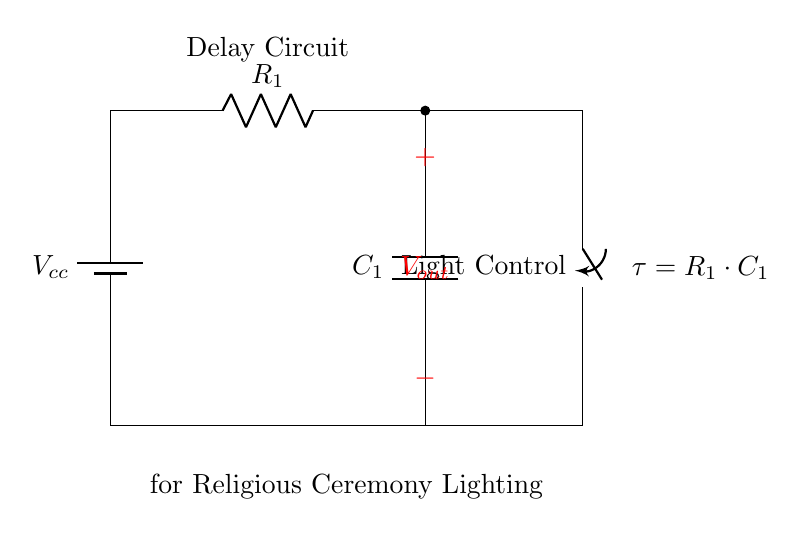What are the main components in this circuit? The main components are a resistor, a capacitor, and a switch. The resistor is labeled as R1, the capacitor as C1, and the switch is used for controlling the light.
Answer: resistor, capacitor, switch What does the capacitor do in this circuit? The capacitor charges and discharges, creating a delay in the output when the circuit is powered. This charging process determines how quickly the circuit responds, allowing for timed lighting effects.
Answer: Creates delay What is the purpose of the switch in this circuit? The switch controls the on/off state of the lighting connected to the circuit, allowing the lighting to be activated after the delay created by R1 and C1.
Answer: Control lighting What is the time constant of the circuit? The time constant (tau) is calculated using the formula tau equals R1 times C1. This determines how long the delay effect lasts based on the resistor and capacitor values.
Answer: R1 * C1 How does resistance affect the time delay in the circuit? Increasing resistance will increase the time constant, resulting in a longer delay for the lighting effect. Conversely, decreasing resistance will shorten the delay. The relationship is directly proportional.
Answer: Longer delay What will happen if the capacitor is removed from the circuit? If the capacitor is removed, the delay effect will not occur, as the circuit will no longer have a component to store and release energy. The lighting will respond instantly to the switch's position.
Answer: No delay 